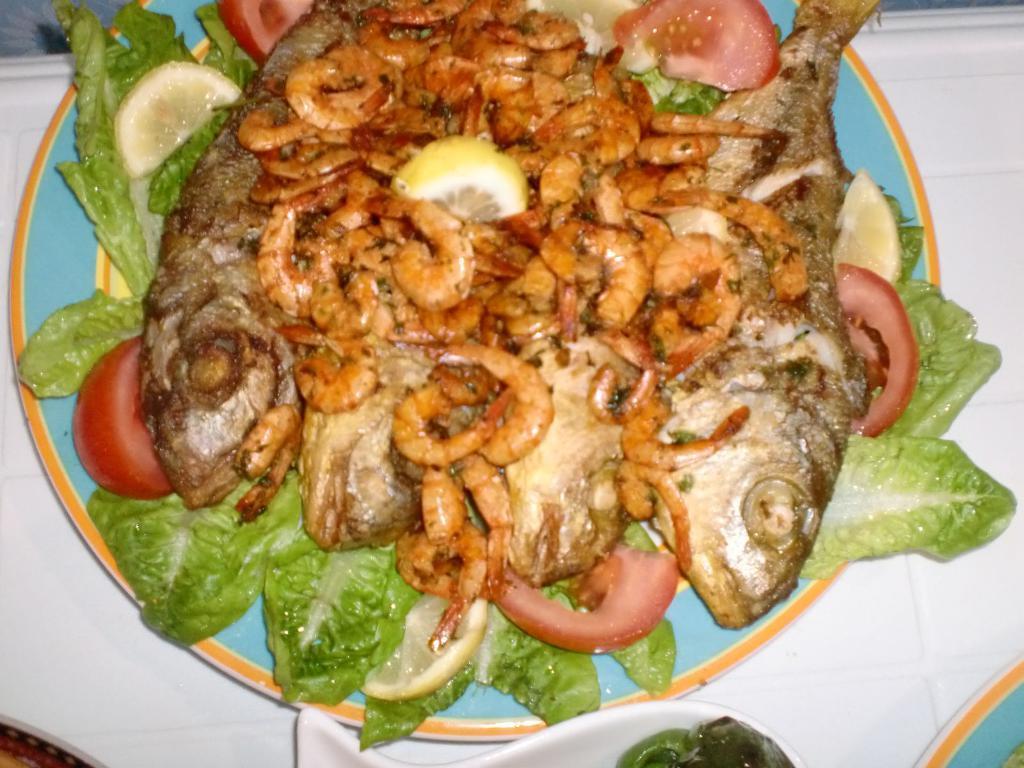Please provide a concise description of this image. This is the picture of a plate in which there are some fishes, prawns and some other things on it. 